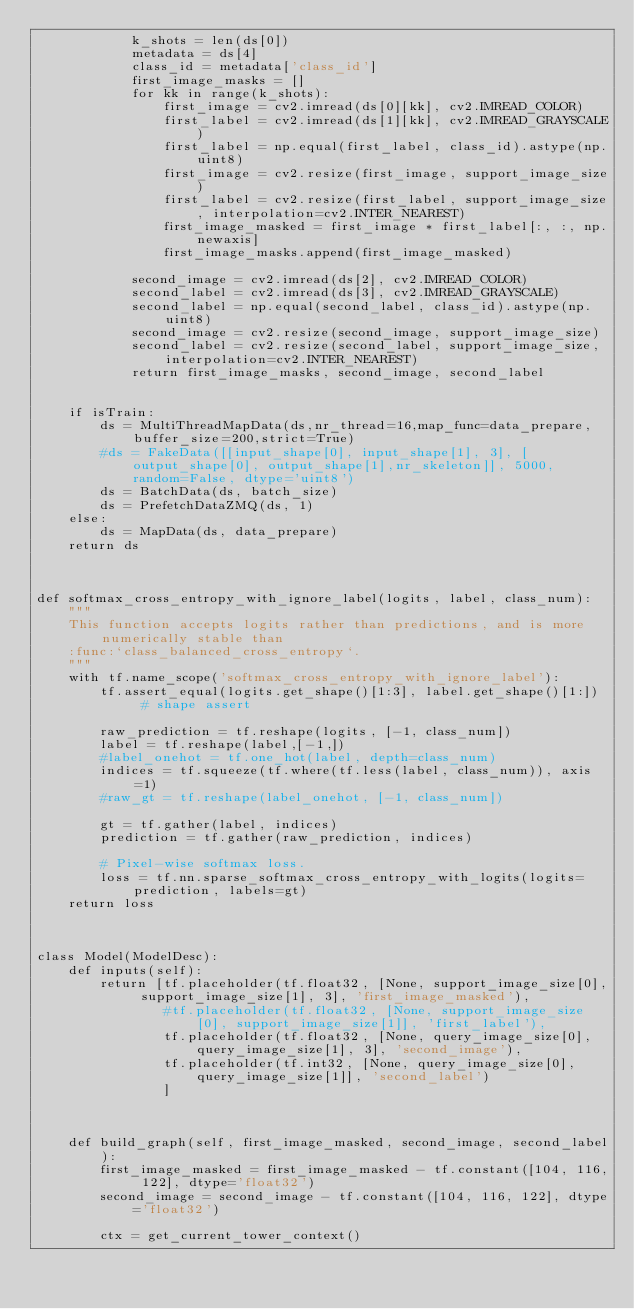Convert code to text. <code><loc_0><loc_0><loc_500><loc_500><_Python_>            k_shots = len(ds[0])
            metadata = ds[4]
            class_id = metadata['class_id']
            first_image_masks = []
            for kk in range(k_shots):
                first_image = cv2.imread(ds[0][kk], cv2.IMREAD_COLOR)
                first_label = cv2.imread(ds[1][kk], cv2.IMREAD_GRAYSCALE)
                first_label = np.equal(first_label, class_id).astype(np.uint8)
                first_image = cv2.resize(first_image, support_image_size)
                first_label = cv2.resize(first_label, support_image_size, interpolation=cv2.INTER_NEAREST)
                first_image_masked = first_image * first_label[:, :, np.newaxis]
                first_image_masks.append(first_image_masked)

            second_image = cv2.imread(ds[2], cv2.IMREAD_COLOR)
            second_label = cv2.imread(ds[3], cv2.IMREAD_GRAYSCALE)
            second_label = np.equal(second_label, class_id).astype(np.uint8)
            second_image = cv2.resize(second_image, support_image_size)
            second_label = cv2.resize(second_label, support_image_size, interpolation=cv2.INTER_NEAREST)
            return first_image_masks, second_image, second_label


    if isTrain:
        ds = MultiThreadMapData(ds,nr_thread=16,map_func=data_prepare,buffer_size=200,strict=True)
        #ds = FakeData([[input_shape[0], input_shape[1], 3], [output_shape[0], output_shape[1],nr_skeleton]], 5000, random=False, dtype='uint8')
        ds = BatchData(ds, batch_size)
        ds = PrefetchDataZMQ(ds, 1)
    else:
        ds = MapData(ds, data_prepare)
    return ds



def softmax_cross_entropy_with_ignore_label(logits, label, class_num):
    """
    This function accepts logits rather than predictions, and is more numerically stable than
    :func:`class_balanced_cross_entropy`.
    """
    with tf.name_scope('softmax_cross_entropy_with_ignore_label'):
        tf.assert_equal(logits.get_shape()[1:3], label.get_shape()[1:])  # shape assert

        raw_prediction = tf.reshape(logits, [-1, class_num])
        label = tf.reshape(label,[-1,])
        #label_onehot = tf.one_hot(label, depth=class_num)
        indices = tf.squeeze(tf.where(tf.less(label, class_num)), axis=1)
        #raw_gt = tf.reshape(label_onehot, [-1, class_num])

        gt = tf.gather(label, indices)
        prediction = tf.gather(raw_prediction, indices)

        # Pixel-wise softmax loss.
        loss = tf.nn.sparse_softmax_cross_entropy_with_logits(logits=prediction, labels=gt)
    return loss



class Model(ModelDesc):
    def inputs(self):
        return [tf.placeholder(tf.float32, [None, support_image_size[0], support_image_size[1], 3], 'first_image_masked'),
                #tf.placeholder(tf.float32, [None, support_image_size[0], support_image_size[1]], 'first_label'),
                tf.placeholder(tf.float32, [None, query_image_size[0], query_image_size[1], 3], 'second_image'),
                tf.placeholder(tf.int32, [None, query_image_size[0], query_image_size[1]], 'second_label')
                ]



    def build_graph(self, first_image_masked, second_image, second_label):
        first_image_masked = first_image_masked - tf.constant([104, 116, 122], dtype='float32')
        second_image = second_image - tf.constant([104, 116, 122], dtype='float32')

        ctx = get_current_tower_context()</code> 